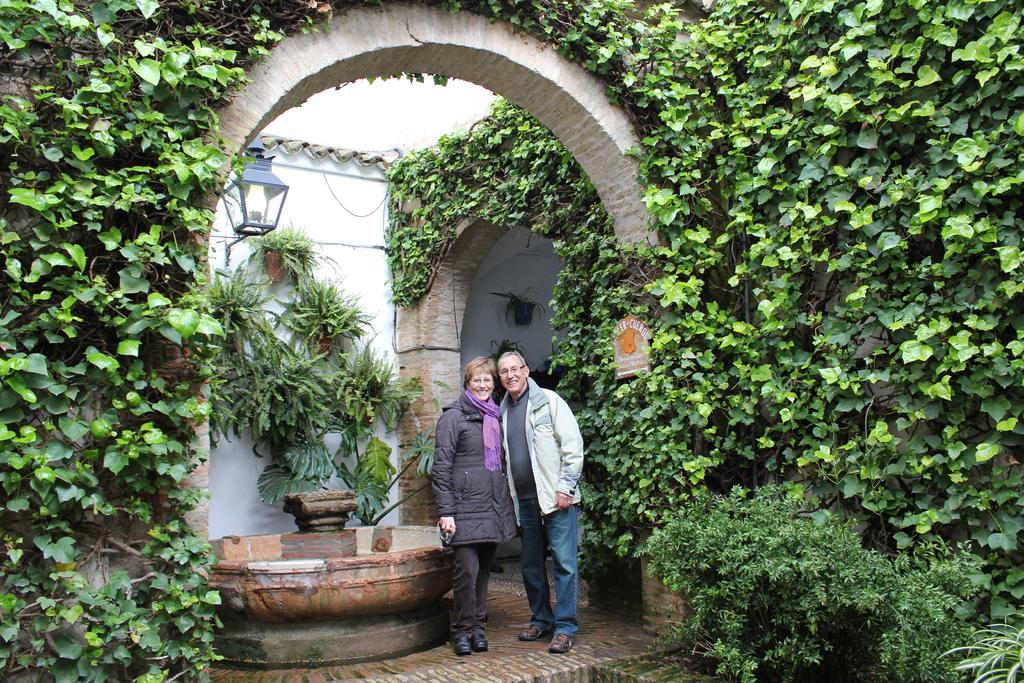How would you summarize this image in a sentence or two? In this image, there are two persons wearing clothes and standing beside the fountain. There is a light in the middle of the image. There are climbing plants on the left and on the right side of the image. 